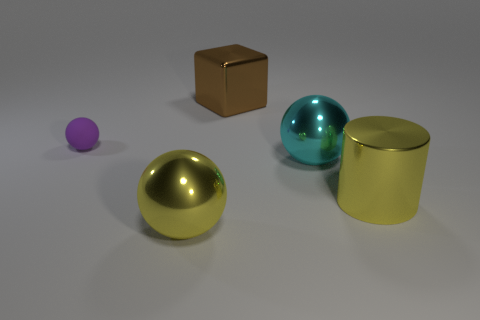Add 1 tiny rubber spheres. How many objects exist? 6 Subtract all metal balls. How many balls are left? 1 Subtract all blue spheres. Subtract all gray cylinders. How many spheres are left? 3 Subtract all cylinders. How many objects are left? 4 Add 2 tiny things. How many tiny things exist? 3 Subtract 0 blue spheres. How many objects are left? 5 Subtract all cylinders. Subtract all spheres. How many objects are left? 1 Add 5 cyan things. How many cyan things are left? 6 